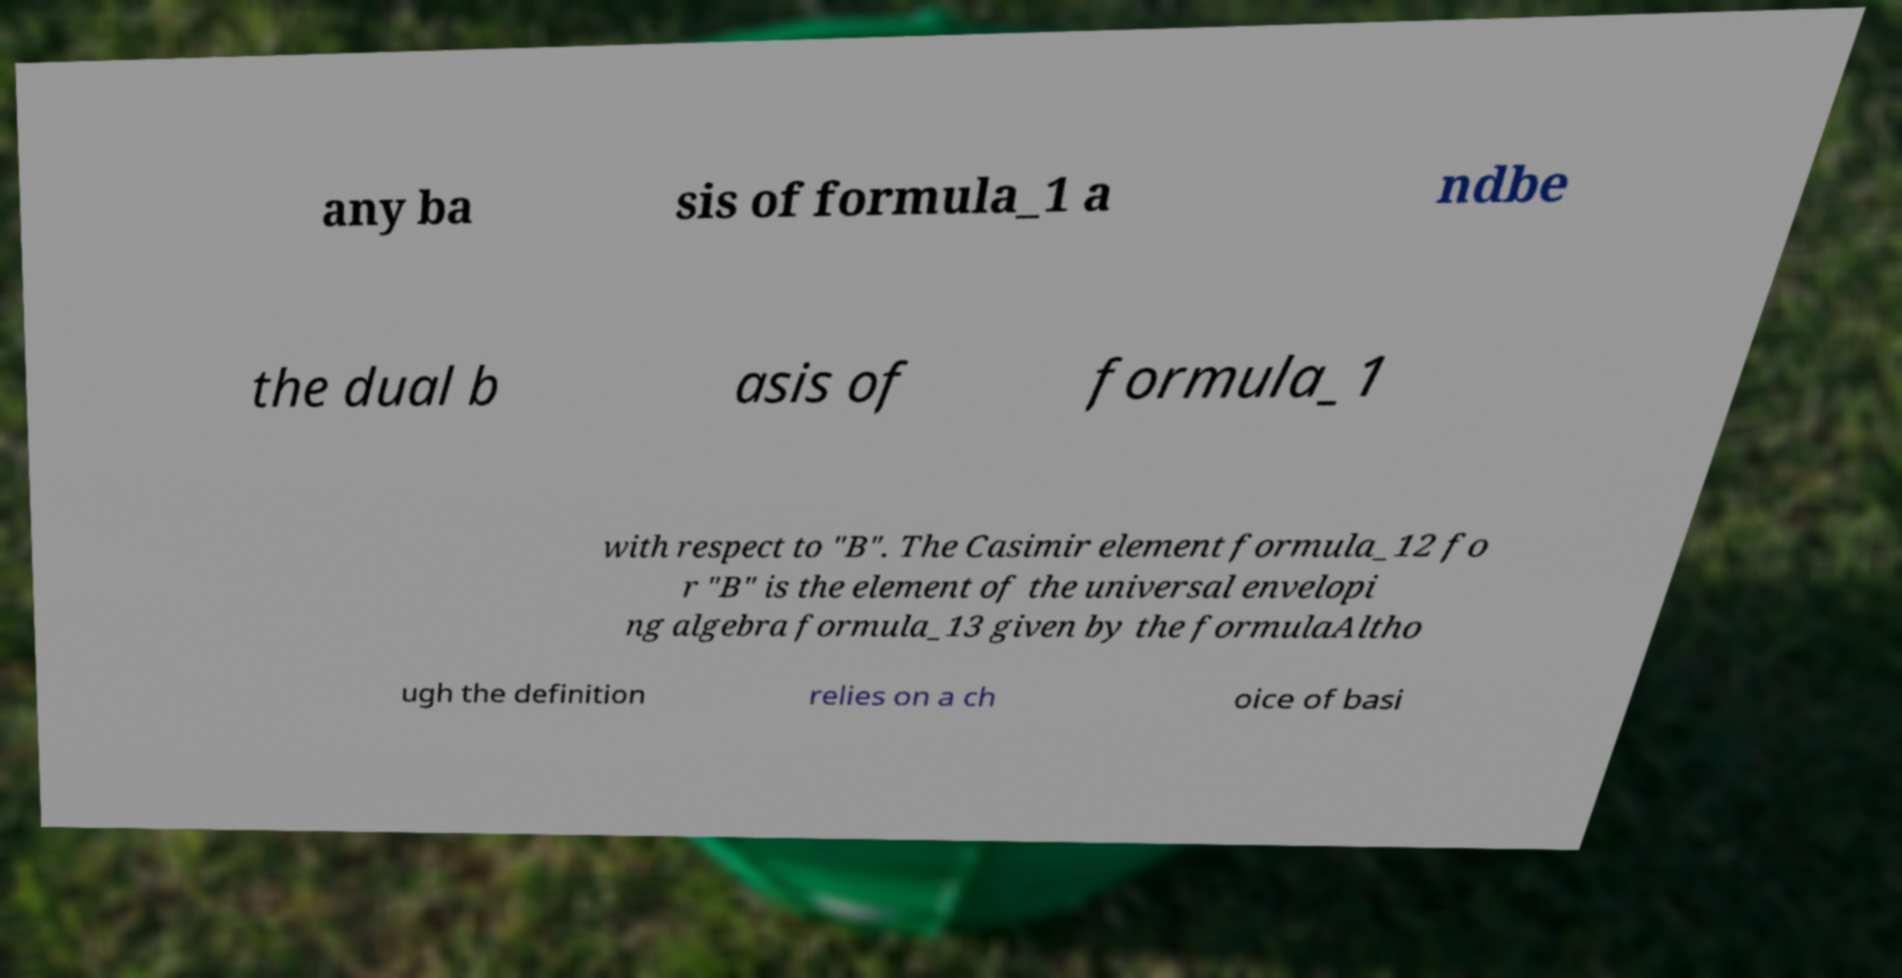Please read and relay the text visible in this image. What does it say? any ba sis of formula_1 a ndbe the dual b asis of formula_1 with respect to "B". The Casimir element formula_12 fo r "B" is the element of the universal envelopi ng algebra formula_13 given by the formulaAltho ugh the definition relies on a ch oice of basi 